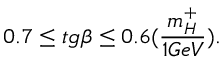<formula> <loc_0><loc_0><loc_500><loc_500>0 . 7 \leq t g \beta \leq 0 . 6 ( \frac { m _ { H } ^ { + } } { 1 G e V } ) .</formula> 